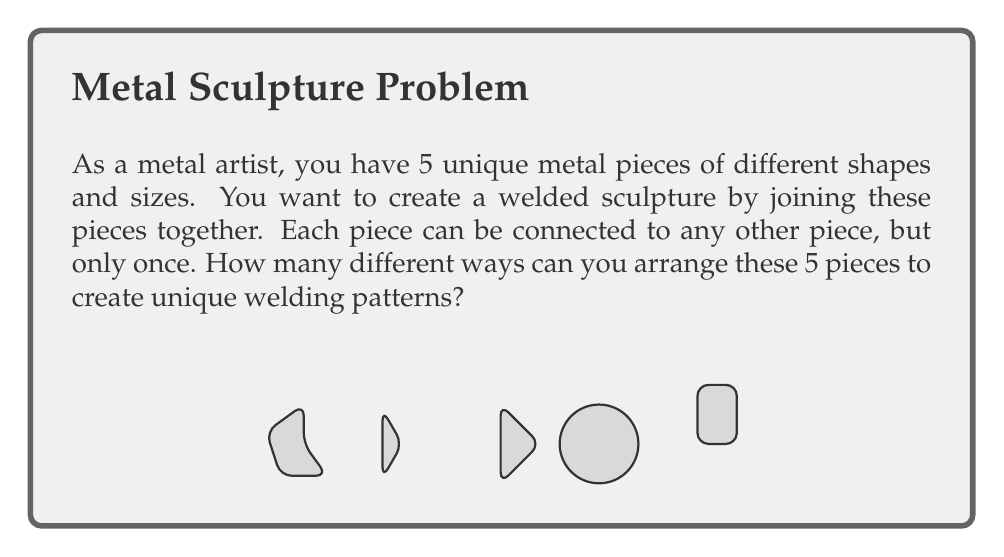Help me with this question. Let's approach this step-by-step:

1) This problem is equivalent to finding the number of unique ways to connect 5 nodes in a graph, where each connection represents a weld.

2) In graph theory, a graph with all nodes connected but with no cycles is called a tree. We're looking for the number of unique labeled trees with 5 nodes.

3) Cayley's formula states that for n labeled nodes, the number of unique trees is $n^{n-2}$.

4) In our case, $n = 5$, so we need to calculate $5^{5-2} = 5^3$.

5) Let's compute this:
   $$5^3 = 5 \times 5 \times 5 = 125$$

Therefore, there are 125 unique ways to arrange and weld these 5 metal pieces.
Answer: $125$ 